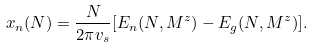<formula> <loc_0><loc_0><loc_500><loc_500>x _ { n } ( N ) = \frac { N } { 2 \pi v _ { s } } [ E _ { n } ( N , M ^ { z } ) - E _ { g } ( N , M ^ { z } ) ] .</formula> 